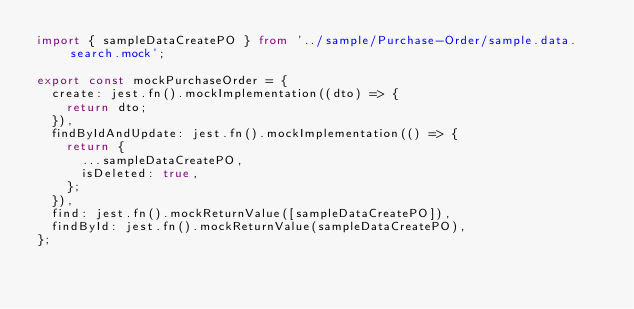<code> <loc_0><loc_0><loc_500><loc_500><_TypeScript_>import { sampleDataCreatePO } from '../sample/Purchase-Order/sample.data.search.mock';

export const mockPurchaseOrder = {
  create: jest.fn().mockImplementation((dto) => {
    return dto;
  }),
  findByIdAndUpdate: jest.fn().mockImplementation(() => {
    return {
      ...sampleDataCreatePO,
      isDeleted: true,
    };
  }),
  find: jest.fn().mockReturnValue([sampleDataCreatePO]),
  findById: jest.fn().mockReturnValue(sampleDataCreatePO),
};
</code> 